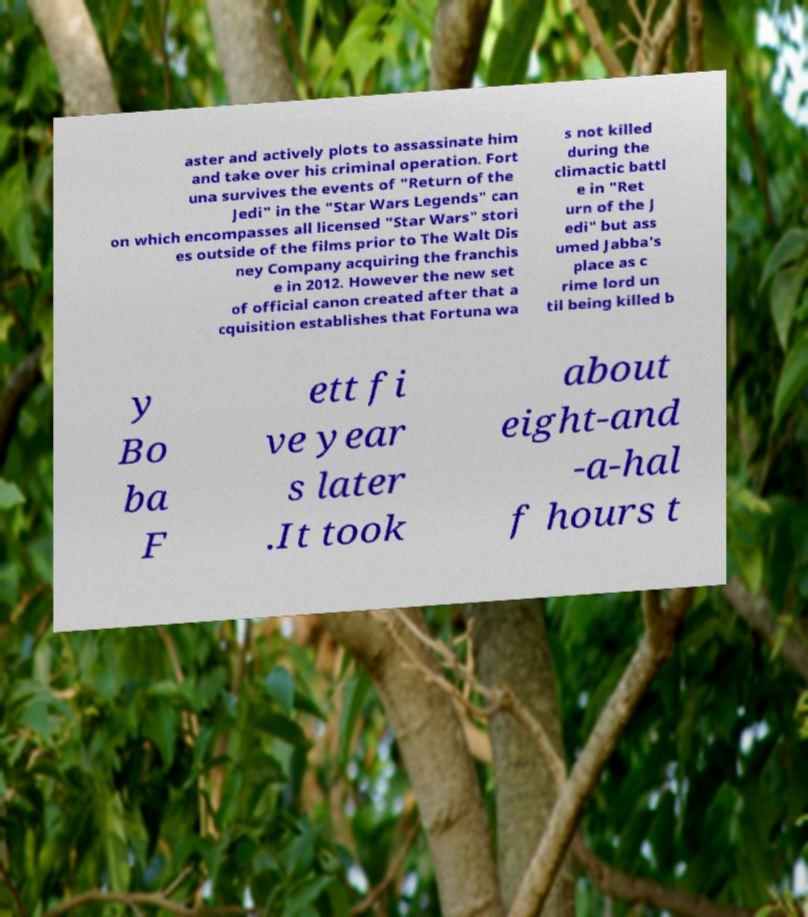What messages or text are displayed in this image? I need them in a readable, typed format. aster and actively plots to assassinate him and take over his criminal operation. Fort una survives the events of "Return of the Jedi" in the "Star Wars Legends" can on which encompasses all licensed "Star Wars" stori es outside of the films prior to The Walt Dis ney Company acquiring the franchis e in 2012. However the new set of official canon created after that a cquisition establishes that Fortuna wa s not killed during the climactic battl e in "Ret urn of the J edi" but ass umed Jabba's place as c rime lord un til being killed b y Bo ba F ett fi ve year s later .It took about eight-and -a-hal f hours t 